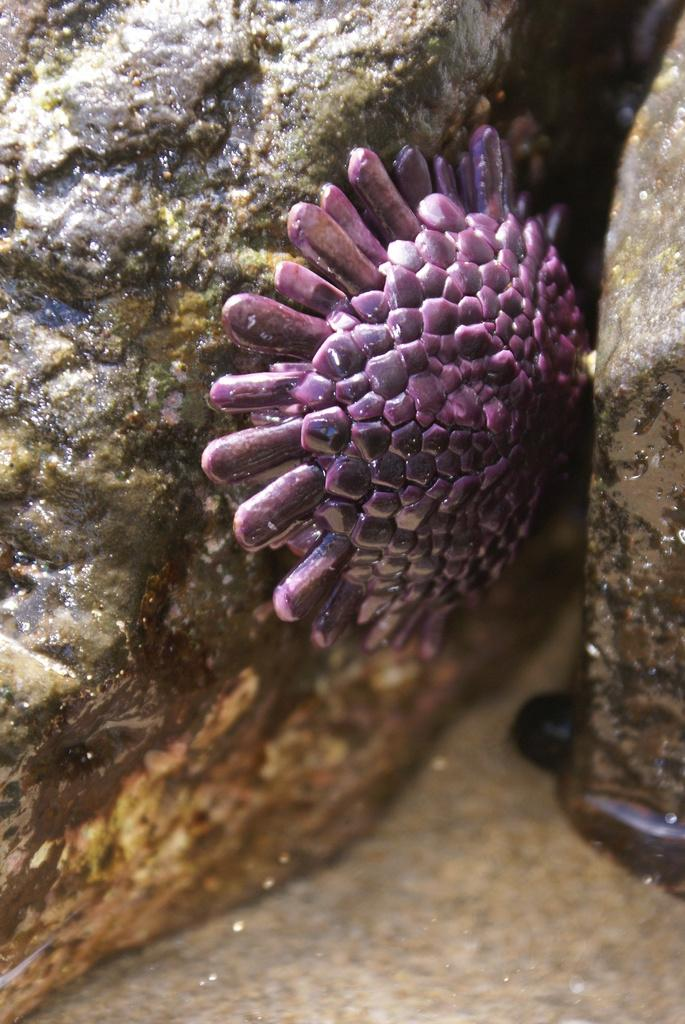What type of water animal is in the image? There is a violet color water animal in the image. Where is the water animal located? The water animal is on a rock. Are there any other rocks visible in the image? Yes, there is another rock in the image, located on the right side. What is the condition of the second rock in the image? The second rock is in the water. Can you tell me how the guide is helping the water animal in the image? There is no guide present in the image, so it is not possible to answer that question. 